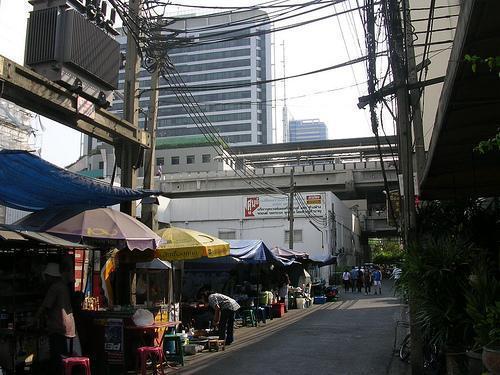Why are there tarps and umbrellas?
Choose the right answer and clarify with the format: 'Answer: answer
Rationale: rationale.'
Options: Construction, beach, raining, market. Answer: market.
Rationale: Markets are set up like this with tarps over stalls. 